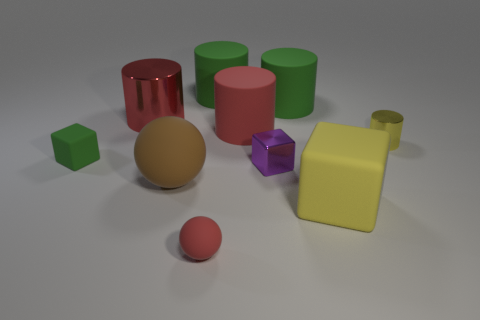Subtract all small cubes. How many cubes are left? 1 Subtract all green spheres. How many green cylinders are left? 2 Subtract all red cylinders. How many cylinders are left? 3 Subtract all brown blocks. Subtract all gray balls. How many blocks are left? 3 Subtract all cubes. How many objects are left? 7 Subtract 0 green spheres. How many objects are left? 10 Subtract all big red metal cylinders. Subtract all large red matte cylinders. How many objects are left? 8 Add 7 yellow rubber objects. How many yellow rubber objects are left? 8 Add 6 tiny yellow shiny balls. How many tiny yellow shiny balls exist? 6 